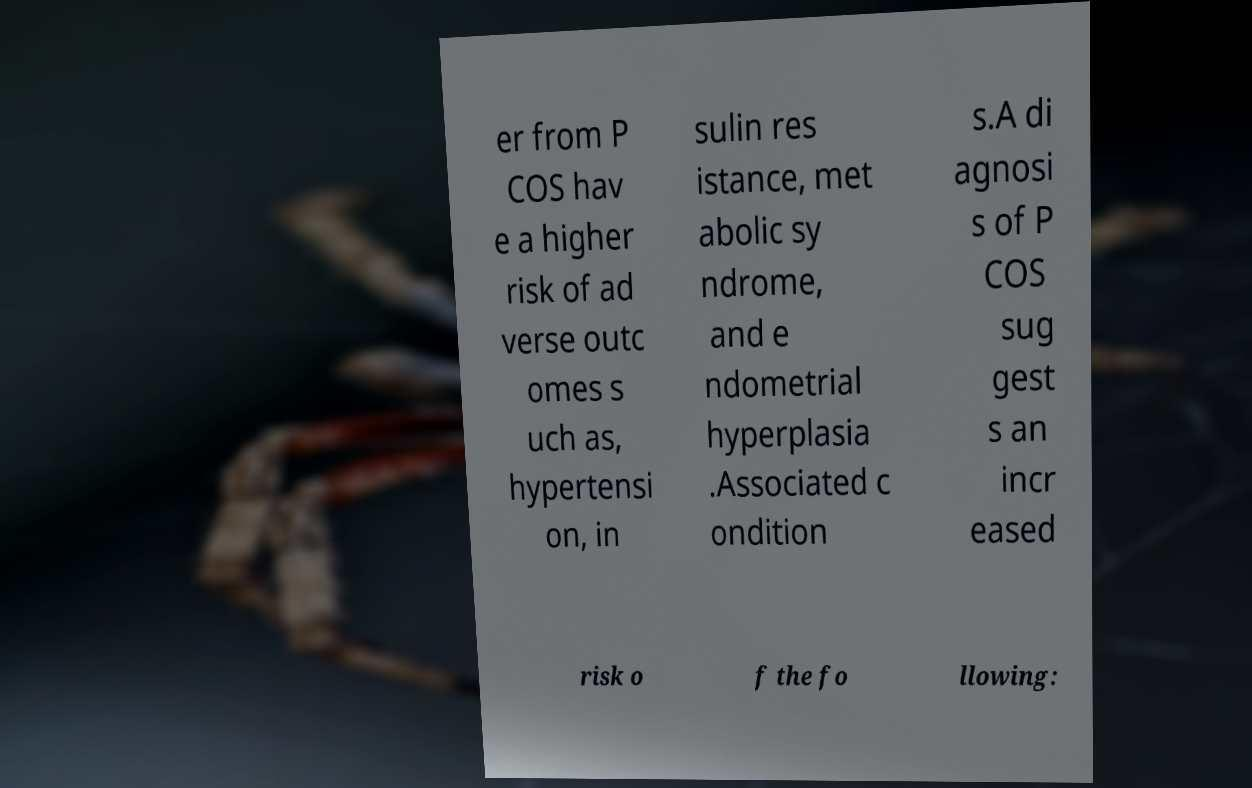For documentation purposes, I need the text within this image transcribed. Could you provide that? er from P COS hav e a higher risk of ad verse outc omes s uch as, hypertensi on, in sulin res istance, met abolic sy ndrome, and e ndometrial hyperplasia .Associated c ondition s.A di agnosi s of P COS sug gest s an incr eased risk o f the fo llowing: 